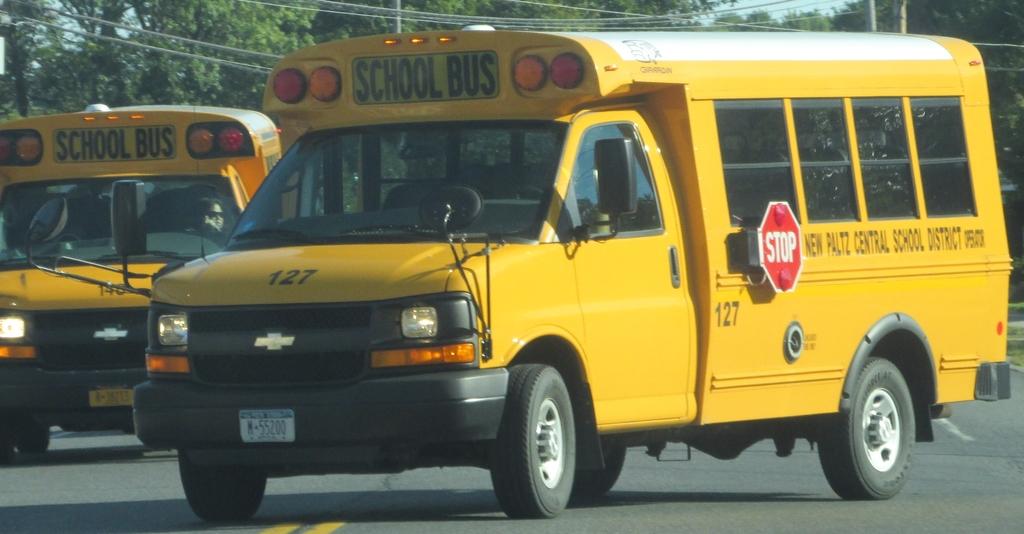Where is the bus going?
Your answer should be compact. School. What kind of service is the bus for?
Keep it short and to the point. School. 